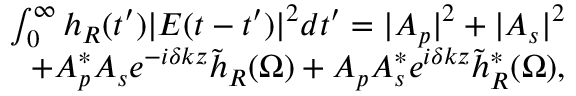<formula> <loc_0><loc_0><loc_500><loc_500>\begin{array} { r } { \int _ { 0 } ^ { \infty } h _ { R } ( t ^ { \prime } ) | E ( t - t ^ { \prime } ) | ^ { 2 } d t ^ { \prime } = | A _ { p } | ^ { 2 } + | A _ { s } | ^ { 2 } } \\ { + A _ { p } ^ { * } A _ { s } e ^ { - i \delta k z } \tilde { h } _ { R } ( \Omega ) + A _ { p } A _ { s } ^ { * } e ^ { i \delta k z } \tilde { h } _ { R } ^ { * } ( \Omega ) , } \end{array}</formula> 